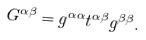<formula> <loc_0><loc_0><loc_500><loc_500>G ^ { \alpha \beta } = g ^ { \alpha \alpha } t ^ { \alpha \beta } g ^ { \beta \beta } .</formula> 